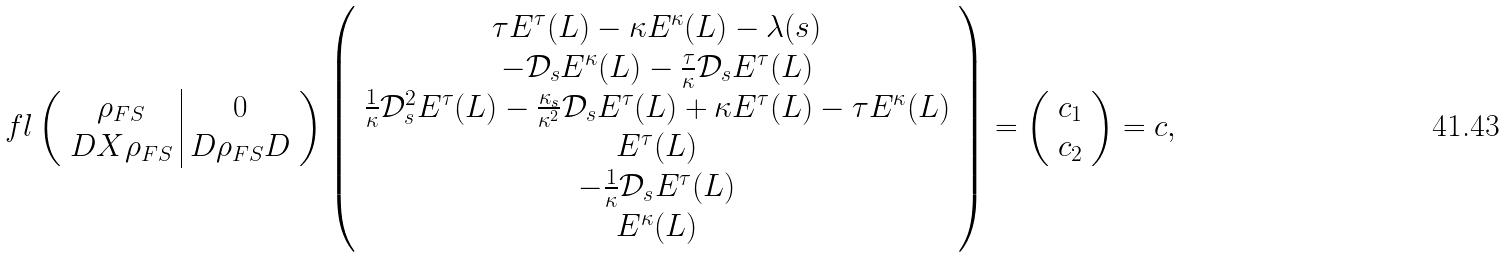<formula> <loc_0><loc_0><loc_500><loc_500>\ f l \left ( \begin{array} { c | c } \rho _ { F S } & 0 \\ D X \rho _ { F S } & D \rho _ { F S } D \end{array} \right ) \left ( \begin{array} { c } \tau E ^ { \tau } ( L ) - \kappa E ^ { \kappa } ( L ) - \lambda ( s ) \\ - \mathcal { D } _ { s } E ^ { \kappa } ( L ) - \frac { \tau } { \kappa } \mathcal { D } _ { s } E ^ { \tau } ( L ) \\ \frac { 1 } { \kappa } \mathcal { D } _ { s } ^ { 2 } E ^ { \tau } ( L ) - \frac { \kappa _ { s } } { \kappa ^ { 2 } } \mathcal { D } _ { s } E ^ { \tau } ( L ) + \kappa E ^ { \tau } ( L ) - \tau E ^ { \kappa } ( L ) \\ E ^ { \tau } ( L ) \\ - \frac { 1 } { \kappa } \mathcal { D } _ { s } E ^ { \tau } ( L ) \\ E ^ { \kappa } ( L ) \end{array} \right ) = \left ( \begin{array} { c } c _ { 1 } \\ c _ { 2 } \end{array} \right ) = c ,</formula> 